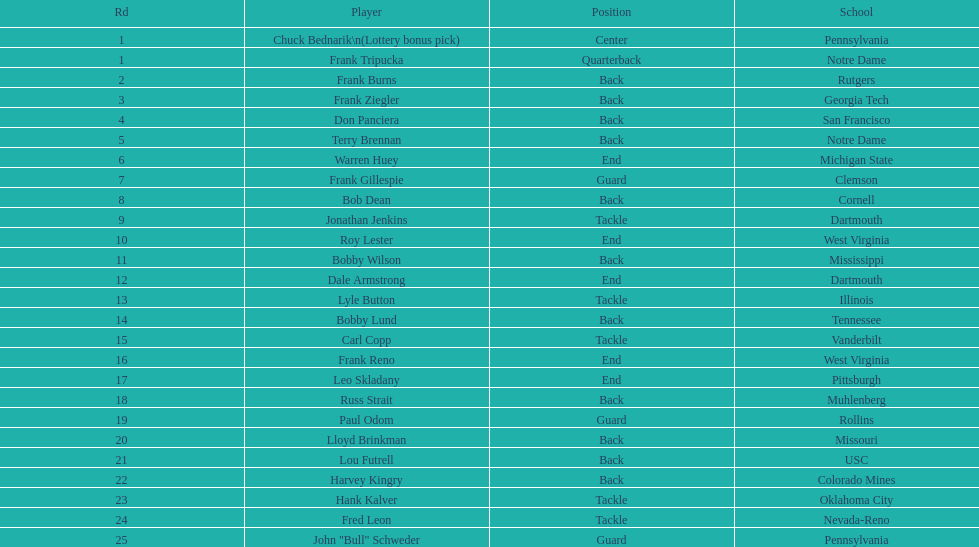Would you mind parsing the complete table? {'header': ['Rd', 'Player', 'Position', 'School'], 'rows': [['1', 'Chuck Bednarik\\n(Lottery bonus pick)', 'Center', 'Pennsylvania'], ['1', 'Frank Tripucka', 'Quarterback', 'Notre Dame'], ['2', 'Frank Burns', 'Back', 'Rutgers'], ['3', 'Frank Ziegler', 'Back', 'Georgia Tech'], ['4', 'Don Panciera', 'Back', 'San Francisco'], ['5', 'Terry Brennan', 'Back', 'Notre Dame'], ['6', 'Warren Huey', 'End', 'Michigan State'], ['7', 'Frank Gillespie', 'Guard', 'Clemson'], ['8', 'Bob Dean', 'Back', 'Cornell'], ['9', 'Jonathan Jenkins', 'Tackle', 'Dartmouth'], ['10', 'Roy Lester', 'End', 'West Virginia'], ['11', 'Bobby Wilson', 'Back', 'Mississippi'], ['12', 'Dale Armstrong', 'End', 'Dartmouth'], ['13', 'Lyle Button', 'Tackle', 'Illinois'], ['14', 'Bobby Lund', 'Back', 'Tennessee'], ['15', 'Carl Copp', 'Tackle', 'Vanderbilt'], ['16', 'Frank Reno', 'End', 'West Virginia'], ['17', 'Leo Skladany', 'End', 'Pittsburgh'], ['18', 'Russ Strait', 'Back', 'Muhlenberg'], ['19', 'Paul Odom', 'Guard', 'Rollins'], ['20', 'Lloyd Brinkman', 'Back', 'Missouri'], ['21', 'Lou Futrell', 'Back', 'USC'], ['22', 'Harvey Kingry', 'Back', 'Colorado Mines'], ['23', 'Hank Kalver', 'Tackle', 'Oklahoma City'], ['24', 'Fred Leon', 'Tackle', 'Nevada-Reno'], ['25', 'John "Bull" Schweder', 'Guard', 'Pennsylvania']]} How many draft picks were between frank tripucka and dale armstrong? 10. 